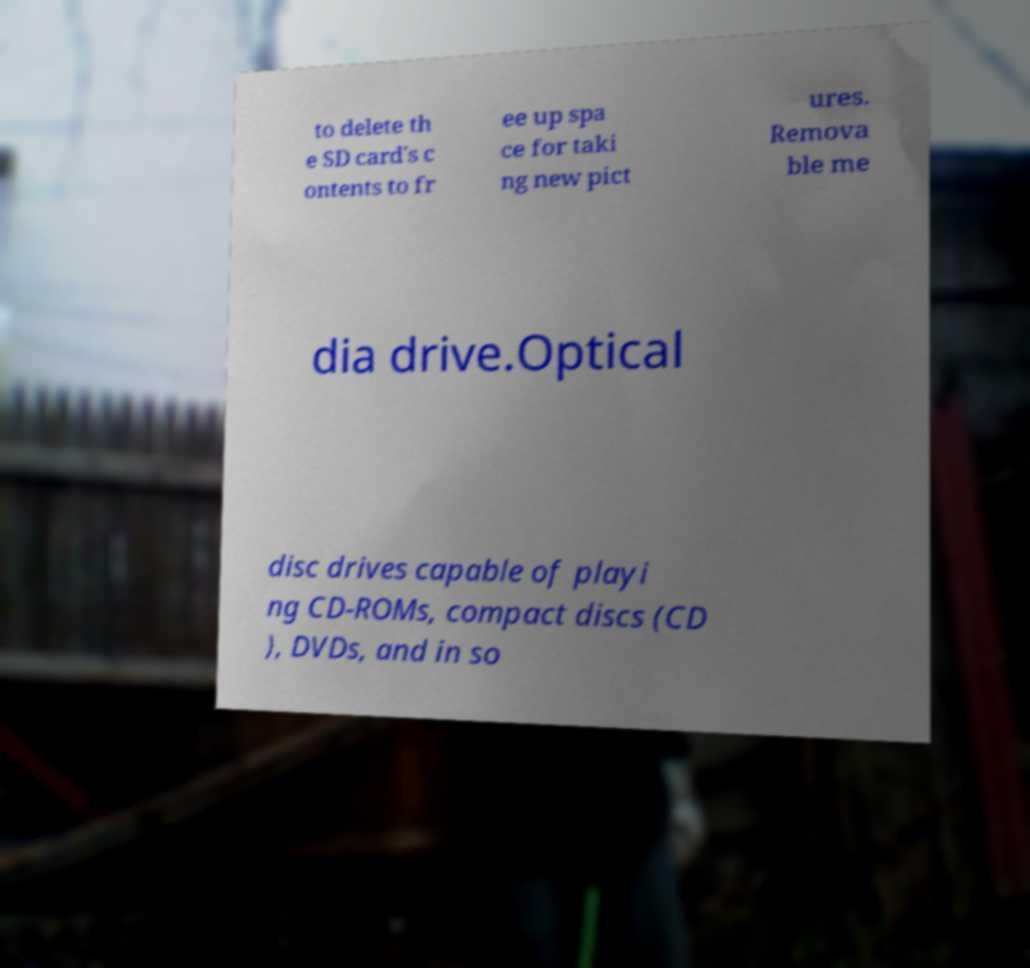I need the written content from this picture converted into text. Can you do that? to delete th e SD card's c ontents to fr ee up spa ce for taki ng new pict ures. Remova ble me dia drive.Optical disc drives capable of playi ng CD-ROMs, compact discs (CD ), DVDs, and in so 